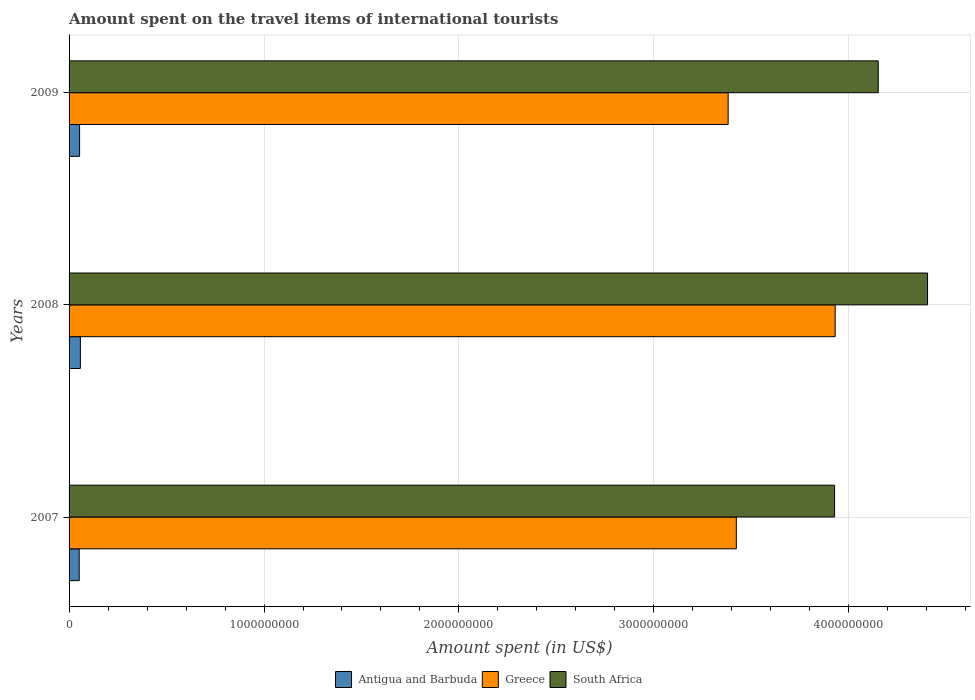How many different coloured bars are there?
Offer a very short reply. 3. How many groups of bars are there?
Your answer should be compact. 3. Are the number of bars on each tick of the Y-axis equal?
Offer a very short reply. Yes. How many bars are there on the 2nd tick from the bottom?
Ensure brevity in your answer.  3. In how many cases, is the number of bars for a given year not equal to the number of legend labels?
Keep it short and to the point. 0. What is the amount spent on the travel items of international tourists in Antigua and Barbuda in 2009?
Provide a short and direct response. 5.40e+07. Across all years, what is the maximum amount spent on the travel items of international tourists in South Africa?
Offer a very short reply. 4.40e+09. Across all years, what is the minimum amount spent on the travel items of international tourists in Greece?
Make the answer very short. 3.38e+09. In which year was the amount spent on the travel items of international tourists in Antigua and Barbuda maximum?
Give a very brief answer. 2008. In which year was the amount spent on the travel items of international tourists in South Africa minimum?
Your answer should be very brief. 2007. What is the total amount spent on the travel items of international tourists in Greece in the graph?
Give a very brief answer. 1.07e+1. What is the difference between the amount spent on the travel items of international tourists in South Africa in 2007 and that in 2008?
Your answer should be very brief. -4.77e+08. What is the difference between the amount spent on the travel items of international tourists in South Africa in 2009 and the amount spent on the travel items of international tourists in Antigua and Barbuda in 2007?
Your response must be concise. 4.10e+09. What is the average amount spent on the travel items of international tourists in South Africa per year?
Keep it short and to the point. 4.16e+09. In the year 2009, what is the difference between the amount spent on the travel items of international tourists in Antigua and Barbuda and amount spent on the travel items of international tourists in Greece?
Your answer should be very brief. -3.33e+09. What is the ratio of the amount spent on the travel items of international tourists in Greece in 2007 to that in 2009?
Provide a short and direct response. 1.01. Is the difference between the amount spent on the travel items of international tourists in Antigua and Barbuda in 2007 and 2009 greater than the difference between the amount spent on the travel items of international tourists in Greece in 2007 and 2009?
Keep it short and to the point. No. What is the difference between the highest and the second highest amount spent on the travel items of international tourists in South Africa?
Provide a succinct answer. 2.53e+08. What is the difference between the highest and the lowest amount spent on the travel items of international tourists in Antigua and Barbuda?
Provide a short and direct response. 6.00e+06. Is the sum of the amount spent on the travel items of international tourists in Antigua and Barbuda in 2007 and 2008 greater than the maximum amount spent on the travel items of international tourists in Greece across all years?
Ensure brevity in your answer.  No. What does the 1st bar from the bottom in 2009 represents?
Make the answer very short. Antigua and Barbuda. Is it the case that in every year, the sum of the amount spent on the travel items of international tourists in South Africa and amount spent on the travel items of international tourists in Antigua and Barbuda is greater than the amount spent on the travel items of international tourists in Greece?
Offer a terse response. Yes. What is the difference between two consecutive major ticks on the X-axis?
Provide a short and direct response. 1.00e+09. Are the values on the major ticks of X-axis written in scientific E-notation?
Keep it short and to the point. No. Does the graph contain any zero values?
Provide a succinct answer. No. How many legend labels are there?
Offer a very short reply. 3. What is the title of the graph?
Provide a succinct answer. Amount spent on the travel items of international tourists. What is the label or title of the X-axis?
Provide a succinct answer. Amount spent (in US$). What is the Amount spent (in US$) of Antigua and Barbuda in 2007?
Give a very brief answer. 5.20e+07. What is the Amount spent (in US$) of Greece in 2007?
Keep it short and to the point. 3.42e+09. What is the Amount spent (in US$) of South Africa in 2007?
Keep it short and to the point. 3.93e+09. What is the Amount spent (in US$) of Antigua and Barbuda in 2008?
Your response must be concise. 5.80e+07. What is the Amount spent (in US$) of Greece in 2008?
Ensure brevity in your answer.  3.93e+09. What is the Amount spent (in US$) of South Africa in 2008?
Your response must be concise. 4.40e+09. What is the Amount spent (in US$) of Antigua and Barbuda in 2009?
Your answer should be very brief. 5.40e+07. What is the Amount spent (in US$) in Greece in 2009?
Your answer should be compact. 3.38e+09. What is the Amount spent (in US$) of South Africa in 2009?
Provide a short and direct response. 4.15e+09. Across all years, what is the maximum Amount spent (in US$) in Antigua and Barbuda?
Your answer should be very brief. 5.80e+07. Across all years, what is the maximum Amount spent (in US$) of Greece?
Offer a terse response. 3.93e+09. Across all years, what is the maximum Amount spent (in US$) of South Africa?
Your answer should be compact. 4.40e+09. Across all years, what is the minimum Amount spent (in US$) of Antigua and Barbuda?
Offer a very short reply. 5.20e+07. Across all years, what is the minimum Amount spent (in US$) of Greece?
Your answer should be very brief. 3.38e+09. Across all years, what is the minimum Amount spent (in US$) of South Africa?
Provide a short and direct response. 3.93e+09. What is the total Amount spent (in US$) in Antigua and Barbuda in the graph?
Offer a very short reply. 1.64e+08. What is the total Amount spent (in US$) of Greece in the graph?
Your answer should be very brief. 1.07e+1. What is the total Amount spent (in US$) in South Africa in the graph?
Offer a terse response. 1.25e+1. What is the difference between the Amount spent (in US$) in Antigua and Barbuda in 2007 and that in 2008?
Your answer should be compact. -6.00e+06. What is the difference between the Amount spent (in US$) in Greece in 2007 and that in 2008?
Provide a short and direct response. -5.07e+08. What is the difference between the Amount spent (in US$) of South Africa in 2007 and that in 2008?
Your answer should be very brief. -4.77e+08. What is the difference between the Amount spent (in US$) in Greece in 2007 and that in 2009?
Offer a terse response. 4.20e+07. What is the difference between the Amount spent (in US$) in South Africa in 2007 and that in 2009?
Your answer should be very brief. -2.24e+08. What is the difference between the Amount spent (in US$) in Greece in 2008 and that in 2009?
Provide a short and direct response. 5.49e+08. What is the difference between the Amount spent (in US$) in South Africa in 2008 and that in 2009?
Provide a short and direct response. 2.53e+08. What is the difference between the Amount spent (in US$) of Antigua and Barbuda in 2007 and the Amount spent (in US$) of Greece in 2008?
Make the answer very short. -3.88e+09. What is the difference between the Amount spent (in US$) of Antigua and Barbuda in 2007 and the Amount spent (in US$) of South Africa in 2008?
Provide a succinct answer. -4.35e+09. What is the difference between the Amount spent (in US$) in Greece in 2007 and the Amount spent (in US$) in South Africa in 2008?
Give a very brief answer. -9.81e+08. What is the difference between the Amount spent (in US$) of Antigua and Barbuda in 2007 and the Amount spent (in US$) of Greece in 2009?
Provide a succinct answer. -3.33e+09. What is the difference between the Amount spent (in US$) of Antigua and Barbuda in 2007 and the Amount spent (in US$) of South Africa in 2009?
Offer a very short reply. -4.10e+09. What is the difference between the Amount spent (in US$) in Greece in 2007 and the Amount spent (in US$) in South Africa in 2009?
Make the answer very short. -7.28e+08. What is the difference between the Amount spent (in US$) of Antigua and Barbuda in 2008 and the Amount spent (in US$) of Greece in 2009?
Your response must be concise. -3.32e+09. What is the difference between the Amount spent (in US$) in Antigua and Barbuda in 2008 and the Amount spent (in US$) in South Africa in 2009?
Give a very brief answer. -4.09e+09. What is the difference between the Amount spent (in US$) in Greece in 2008 and the Amount spent (in US$) in South Africa in 2009?
Provide a succinct answer. -2.21e+08. What is the average Amount spent (in US$) in Antigua and Barbuda per year?
Make the answer very short. 5.47e+07. What is the average Amount spent (in US$) in Greece per year?
Offer a very short reply. 3.58e+09. What is the average Amount spent (in US$) of South Africa per year?
Offer a very short reply. 4.16e+09. In the year 2007, what is the difference between the Amount spent (in US$) of Antigua and Barbuda and Amount spent (in US$) of Greece?
Keep it short and to the point. -3.37e+09. In the year 2007, what is the difference between the Amount spent (in US$) of Antigua and Barbuda and Amount spent (in US$) of South Africa?
Your answer should be compact. -3.88e+09. In the year 2007, what is the difference between the Amount spent (in US$) of Greece and Amount spent (in US$) of South Africa?
Your response must be concise. -5.04e+08. In the year 2008, what is the difference between the Amount spent (in US$) of Antigua and Barbuda and Amount spent (in US$) of Greece?
Your response must be concise. -3.87e+09. In the year 2008, what is the difference between the Amount spent (in US$) in Antigua and Barbuda and Amount spent (in US$) in South Africa?
Make the answer very short. -4.35e+09. In the year 2008, what is the difference between the Amount spent (in US$) in Greece and Amount spent (in US$) in South Africa?
Ensure brevity in your answer.  -4.74e+08. In the year 2009, what is the difference between the Amount spent (in US$) in Antigua and Barbuda and Amount spent (in US$) in Greece?
Ensure brevity in your answer.  -3.33e+09. In the year 2009, what is the difference between the Amount spent (in US$) of Antigua and Barbuda and Amount spent (in US$) of South Africa?
Your answer should be very brief. -4.10e+09. In the year 2009, what is the difference between the Amount spent (in US$) in Greece and Amount spent (in US$) in South Africa?
Provide a short and direct response. -7.70e+08. What is the ratio of the Amount spent (in US$) in Antigua and Barbuda in 2007 to that in 2008?
Your response must be concise. 0.9. What is the ratio of the Amount spent (in US$) in Greece in 2007 to that in 2008?
Offer a very short reply. 0.87. What is the ratio of the Amount spent (in US$) in South Africa in 2007 to that in 2008?
Offer a terse response. 0.89. What is the ratio of the Amount spent (in US$) of Antigua and Barbuda in 2007 to that in 2009?
Give a very brief answer. 0.96. What is the ratio of the Amount spent (in US$) of Greece in 2007 to that in 2009?
Give a very brief answer. 1.01. What is the ratio of the Amount spent (in US$) of South Africa in 2007 to that in 2009?
Offer a very short reply. 0.95. What is the ratio of the Amount spent (in US$) of Antigua and Barbuda in 2008 to that in 2009?
Provide a short and direct response. 1.07. What is the ratio of the Amount spent (in US$) of Greece in 2008 to that in 2009?
Ensure brevity in your answer.  1.16. What is the ratio of the Amount spent (in US$) in South Africa in 2008 to that in 2009?
Provide a succinct answer. 1.06. What is the difference between the highest and the second highest Amount spent (in US$) of Greece?
Your response must be concise. 5.07e+08. What is the difference between the highest and the second highest Amount spent (in US$) of South Africa?
Make the answer very short. 2.53e+08. What is the difference between the highest and the lowest Amount spent (in US$) of Antigua and Barbuda?
Your response must be concise. 6.00e+06. What is the difference between the highest and the lowest Amount spent (in US$) of Greece?
Provide a short and direct response. 5.49e+08. What is the difference between the highest and the lowest Amount spent (in US$) of South Africa?
Your response must be concise. 4.77e+08. 